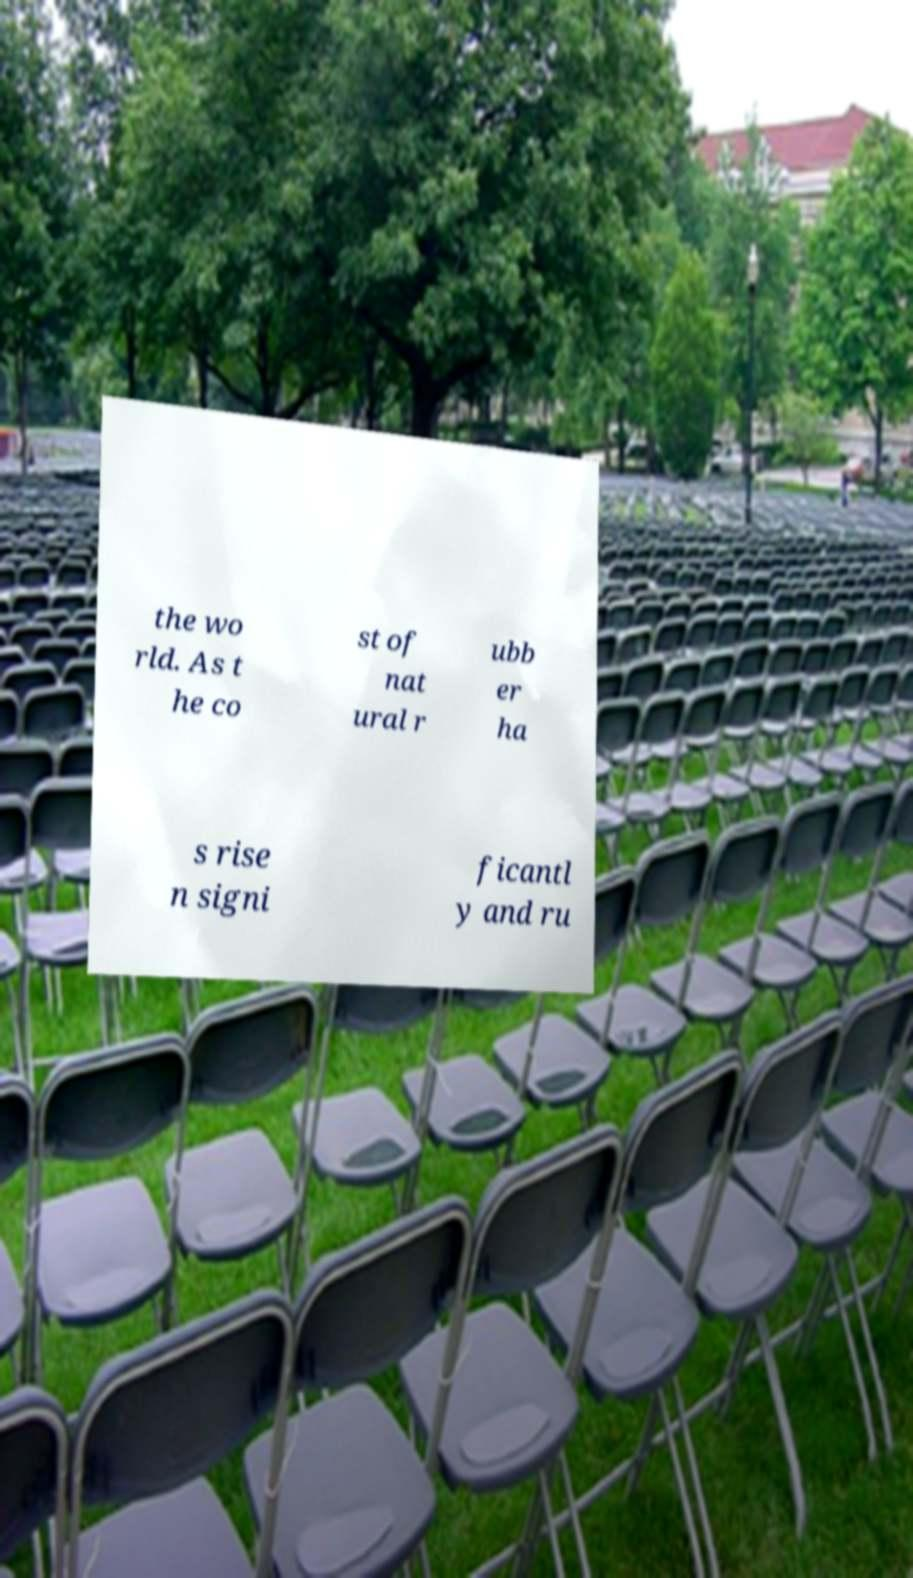There's text embedded in this image that I need extracted. Can you transcribe it verbatim? the wo rld. As t he co st of nat ural r ubb er ha s rise n signi ficantl y and ru 